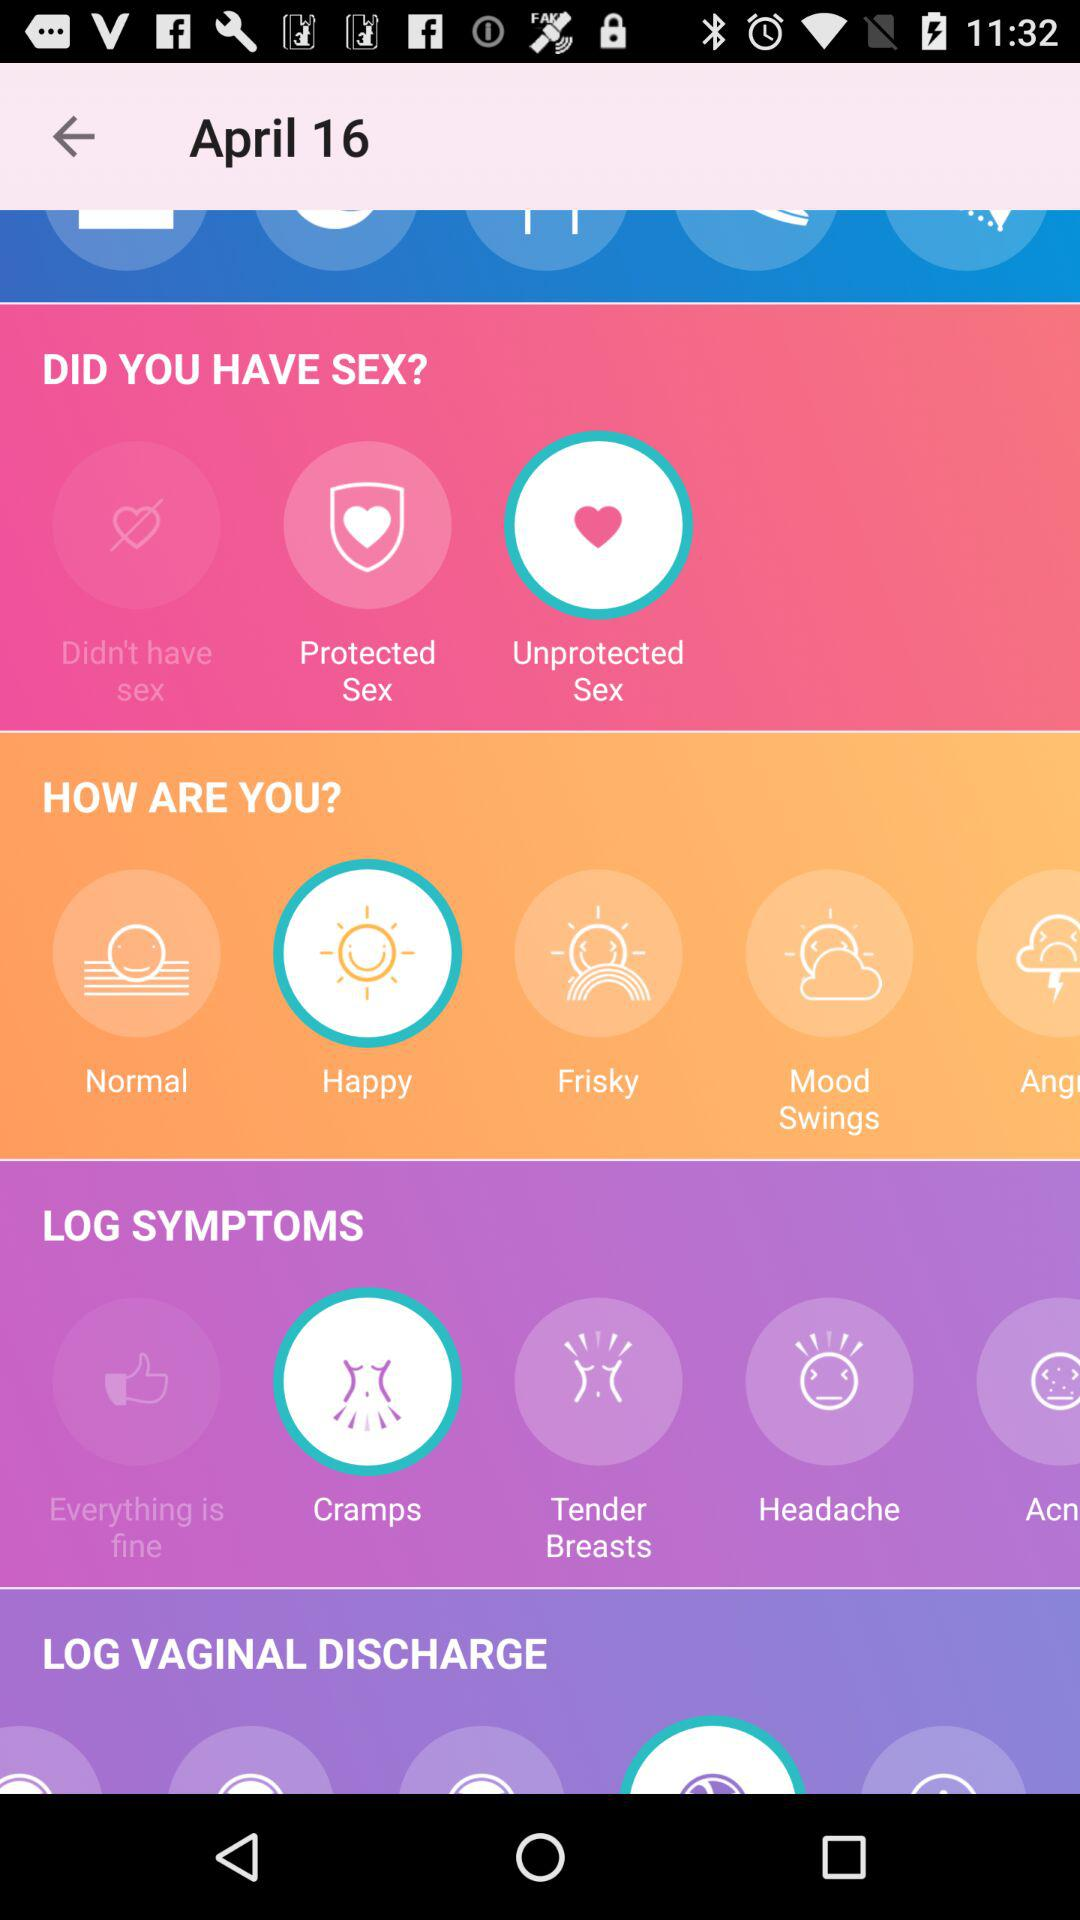Which year were the symptoms logged?
When the provided information is insufficient, respond with <no answer>. <no answer> 